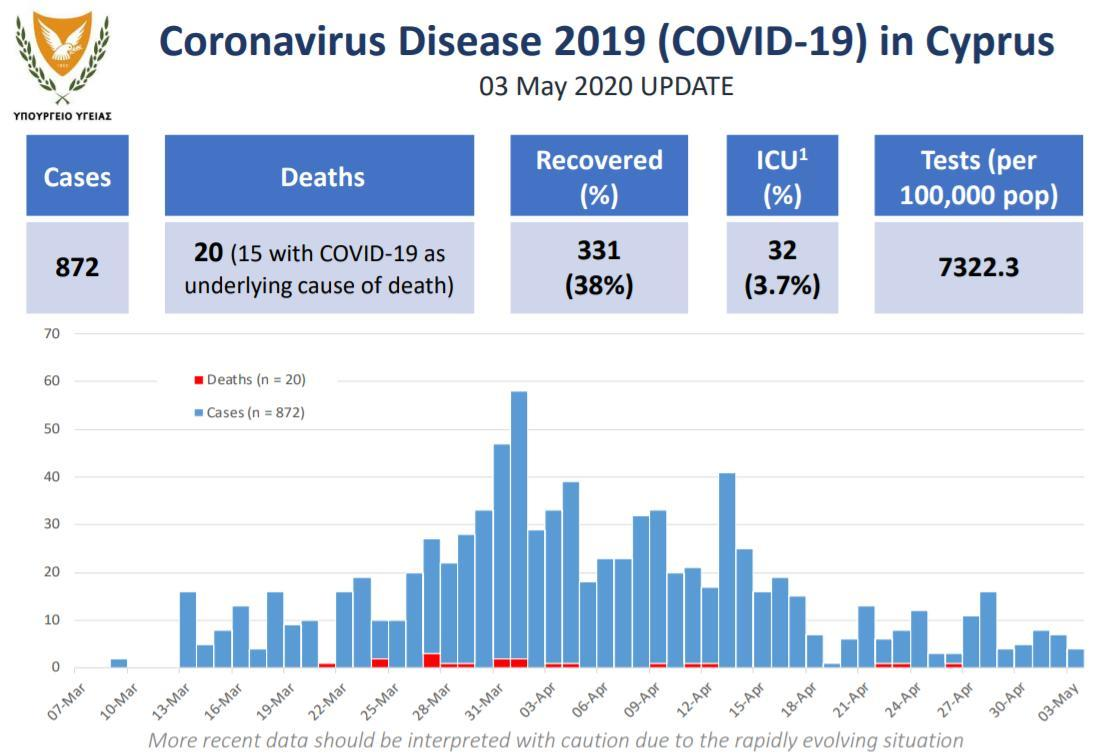How many COVID-19 tests per million population were performed in Cyprus as of 03 May, 2020?
Answer the question with a short phrase. 7322.3 How many COVID-19 patients were admitted in ICU in Cyprus as of 03 May, 2020? 32 What is the total number of COVID-19 cases reported in Cyprus as of 03 May, 2020? 872 What is the number of recovered COVID-19 cases reported in Cyprus as of 03 May, 2020? 331 How many Covid-19 deaths were reported in Cyprus as of 03 May, 2020? 20 